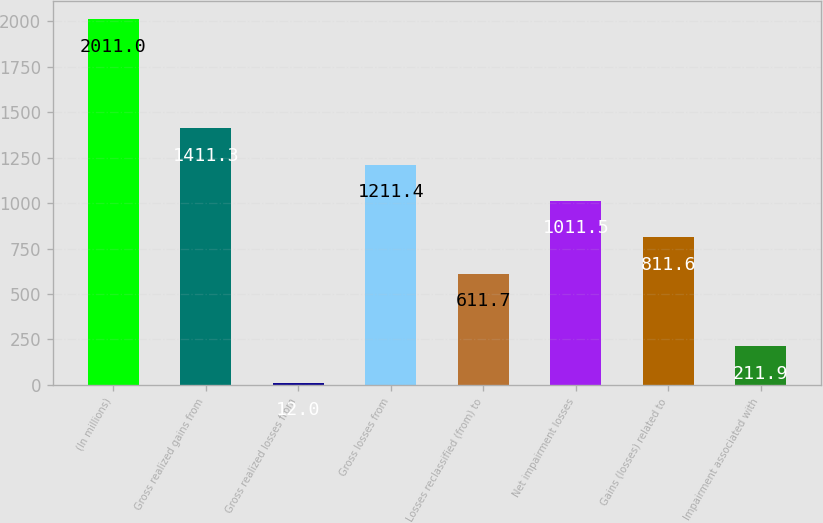<chart> <loc_0><loc_0><loc_500><loc_500><bar_chart><fcel>(In millions)<fcel>Gross realized gains from<fcel>Gross realized losses from<fcel>Gross losses from<fcel>Losses reclassified (from) to<fcel>Net impairment losses<fcel>Gains (losses) related to<fcel>Impairment associated with<nl><fcel>2011<fcel>1411.3<fcel>12<fcel>1211.4<fcel>611.7<fcel>1011.5<fcel>811.6<fcel>211.9<nl></chart> 